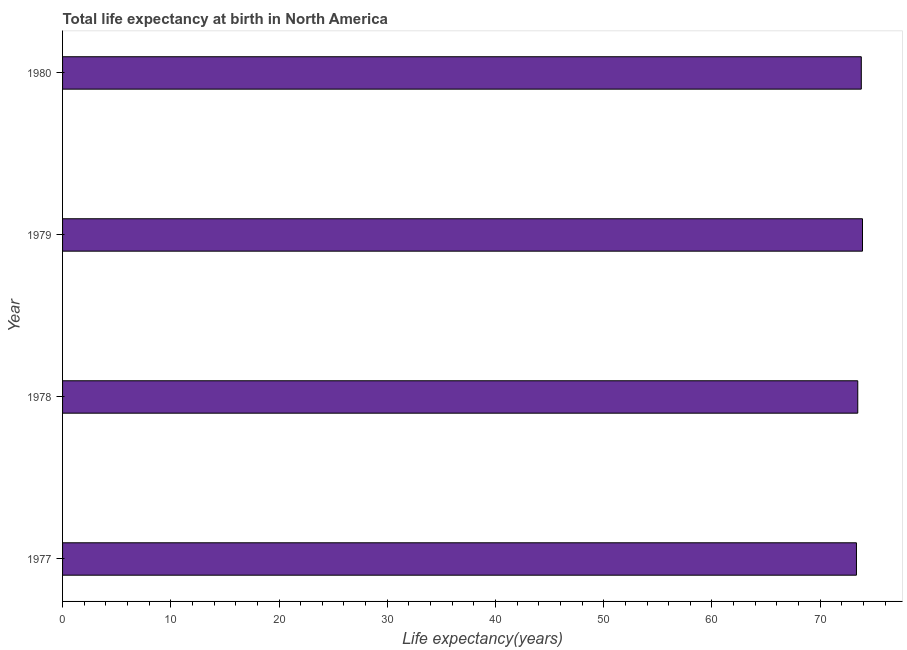Does the graph contain any zero values?
Your answer should be compact. No. What is the title of the graph?
Ensure brevity in your answer.  Total life expectancy at birth in North America. What is the label or title of the X-axis?
Your answer should be compact. Life expectancy(years). What is the life expectancy at birth in 1980?
Your response must be concise. 73.8. Across all years, what is the maximum life expectancy at birth?
Keep it short and to the point. 73.91. Across all years, what is the minimum life expectancy at birth?
Provide a short and direct response. 73.35. In which year was the life expectancy at birth maximum?
Give a very brief answer. 1979. What is the sum of the life expectancy at birth?
Provide a short and direct response. 294.53. What is the difference between the life expectancy at birth in 1977 and 1980?
Keep it short and to the point. -0.45. What is the average life expectancy at birth per year?
Ensure brevity in your answer.  73.63. What is the median life expectancy at birth?
Your answer should be compact. 73.63. In how many years, is the life expectancy at birth greater than 74 years?
Your answer should be very brief. 0. What is the ratio of the life expectancy at birth in 1977 to that in 1980?
Your answer should be compact. 0.99. What is the difference between the highest and the second highest life expectancy at birth?
Offer a terse response. 0.11. Is the sum of the life expectancy at birth in 1978 and 1980 greater than the maximum life expectancy at birth across all years?
Your answer should be very brief. Yes. What is the difference between the highest and the lowest life expectancy at birth?
Offer a terse response. 0.56. Are all the bars in the graph horizontal?
Ensure brevity in your answer.  Yes. How many years are there in the graph?
Your answer should be compact. 4. Are the values on the major ticks of X-axis written in scientific E-notation?
Your answer should be compact. No. What is the Life expectancy(years) in 1977?
Keep it short and to the point. 73.35. What is the Life expectancy(years) in 1978?
Keep it short and to the point. 73.47. What is the Life expectancy(years) of 1979?
Make the answer very short. 73.91. What is the Life expectancy(years) in 1980?
Provide a succinct answer. 73.8. What is the difference between the Life expectancy(years) in 1977 and 1978?
Offer a very short reply. -0.12. What is the difference between the Life expectancy(years) in 1977 and 1979?
Provide a short and direct response. -0.56. What is the difference between the Life expectancy(years) in 1977 and 1980?
Keep it short and to the point. -0.45. What is the difference between the Life expectancy(years) in 1978 and 1979?
Give a very brief answer. -0.44. What is the difference between the Life expectancy(years) in 1978 and 1980?
Offer a very short reply. -0.33. What is the difference between the Life expectancy(years) in 1979 and 1980?
Offer a terse response. 0.11. What is the ratio of the Life expectancy(years) in 1977 to that in 1978?
Make the answer very short. 1. What is the ratio of the Life expectancy(years) in 1977 to that in 1980?
Keep it short and to the point. 0.99. What is the ratio of the Life expectancy(years) in 1978 to that in 1979?
Provide a short and direct response. 0.99. What is the ratio of the Life expectancy(years) in 1978 to that in 1980?
Make the answer very short. 1. 